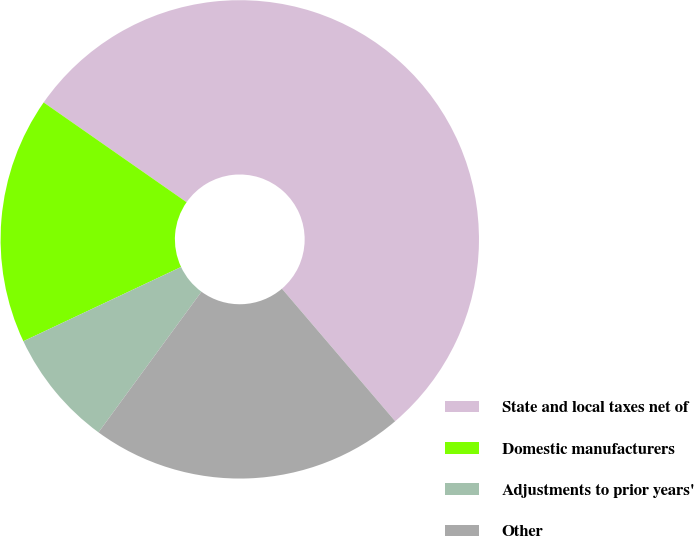<chart> <loc_0><loc_0><loc_500><loc_500><pie_chart><fcel>State and local taxes net of<fcel>Domestic manufacturers<fcel>Adjustments to prior years'<fcel>Other<nl><fcel>54.04%<fcel>16.7%<fcel>7.94%<fcel>21.31%<nl></chart> 